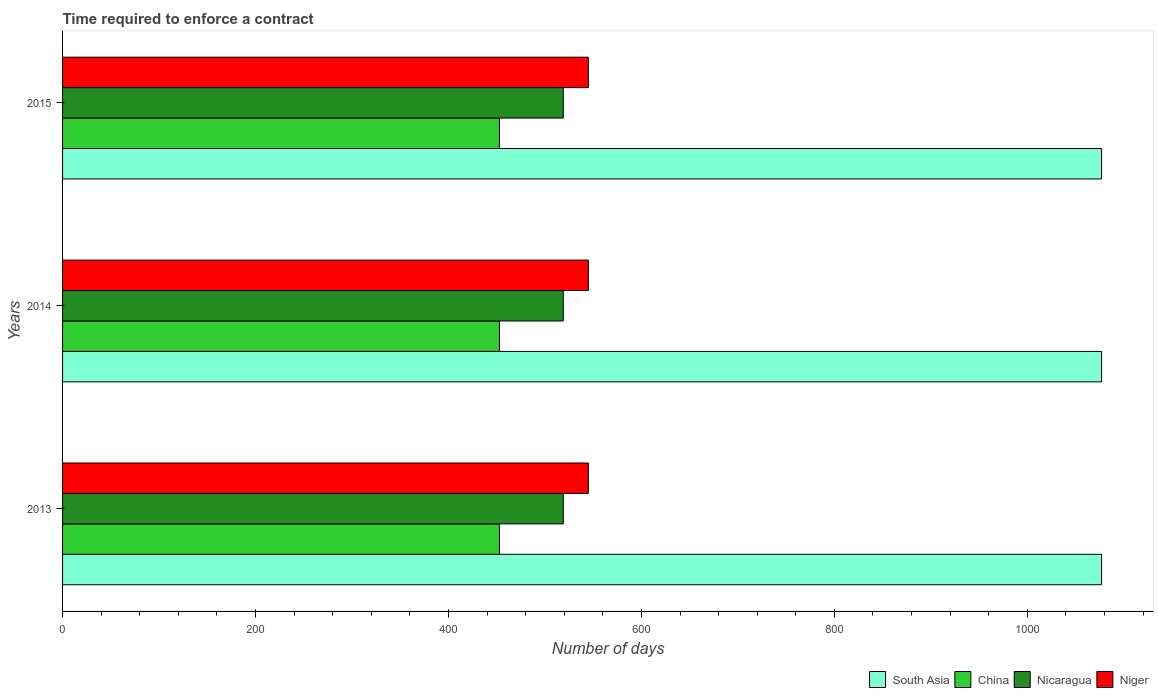Are the number of bars per tick equal to the number of legend labels?
Your answer should be compact. Yes. Are the number of bars on each tick of the Y-axis equal?
Your response must be concise. Yes. How many bars are there on the 3rd tick from the bottom?
Your answer should be very brief. 4. What is the label of the 1st group of bars from the top?
Your response must be concise. 2015. What is the number of days required to enforce a contract in Niger in 2015?
Provide a succinct answer. 545. Across all years, what is the maximum number of days required to enforce a contract in South Asia?
Your answer should be very brief. 1076.9. Across all years, what is the minimum number of days required to enforce a contract in South Asia?
Give a very brief answer. 1076.9. In which year was the number of days required to enforce a contract in China maximum?
Keep it short and to the point. 2013. What is the total number of days required to enforce a contract in Nicaragua in the graph?
Keep it short and to the point. 1557. What is the difference between the number of days required to enforce a contract in China in 2013 and that in 2014?
Keep it short and to the point. 0. What is the difference between the number of days required to enforce a contract in Niger in 2014 and the number of days required to enforce a contract in Nicaragua in 2015?
Your answer should be very brief. 26. What is the average number of days required to enforce a contract in South Asia per year?
Keep it short and to the point. 1076.9. In the year 2015, what is the difference between the number of days required to enforce a contract in Niger and number of days required to enforce a contract in China?
Offer a very short reply. 92.2. In how many years, is the number of days required to enforce a contract in China greater than 840 days?
Provide a short and direct response. 0. Is the number of days required to enforce a contract in China in 2013 less than that in 2014?
Your answer should be very brief. No. Is the difference between the number of days required to enforce a contract in Niger in 2013 and 2015 greater than the difference between the number of days required to enforce a contract in China in 2013 and 2015?
Offer a terse response. No. What is the difference between the highest and the second highest number of days required to enforce a contract in China?
Your answer should be compact. 0. Is it the case that in every year, the sum of the number of days required to enforce a contract in China and number of days required to enforce a contract in Niger is greater than the sum of number of days required to enforce a contract in South Asia and number of days required to enforce a contract in Nicaragua?
Provide a short and direct response. Yes. What does the 1st bar from the top in 2013 represents?
Offer a very short reply. Niger. What does the 4th bar from the bottom in 2013 represents?
Ensure brevity in your answer.  Niger. Is it the case that in every year, the sum of the number of days required to enforce a contract in Nicaragua and number of days required to enforce a contract in South Asia is greater than the number of days required to enforce a contract in Niger?
Keep it short and to the point. Yes. How many bars are there?
Offer a very short reply. 12. Are all the bars in the graph horizontal?
Offer a very short reply. Yes. What is the difference between two consecutive major ticks on the X-axis?
Offer a terse response. 200. Are the values on the major ticks of X-axis written in scientific E-notation?
Your response must be concise. No. Does the graph contain grids?
Keep it short and to the point. No. Where does the legend appear in the graph?
Keep it short and to the point. Bottom right. What is the title of the graph?
Your answer should be compact. Time required to enforce a contract. Does "Bangladesh" appear as one of the legend labels in the graph?
Your answer should be compact. No. What is the label or title of the X-axis?
Provide a short and direct response. Number of days. What is the Number of days of South Asia in 2013?
Offer a very short reply. 1076.9. What is the Number of days in China in 2013?
Ensure brevity in your answer.  452.8. What is the Number of days of Nicaragua in 2013?
Your response must be concise. 519. What is the Number of days in Niger in 2013?
Offer a terse response. 545. What is the Number of days of South Asia in 2014?
Offer a very short reply. 1076.9. What is the Number of days of China in 2014?
Provide a short and direct response. 452.8. What is the Number of days of Nicaragua in 2014?
Give a very brief answer. 519. What is the Number of days of Niger in 2014?
Your answer should be very brief. 545. What is the Number of days in South Asia in 2015?
Ensure brevity in your answer.  1076.9. What is the Number of days in China in 2015?
Keep it short and to the point. 452.8. What is the Number of days of Nicaragua in 2015?
Offer a very short reply. 519. What is the Number of days in Niger in 2015?
Make the answer very short. 545. Across all years, what is the maximum Number of days in South Asia?
Make the answer very short. 1076.9. Across all years, what is the maximum Number of days of China?
Offer a terse response. 452.8. Across all years, what is the maximum Number of days in Nicaragua?
Offer a very short reply. 519. Across all years, what is the maximum Number of days in Niger?
Keep it short and to the point. 545. Across all years, what is the minimum Number of days of South Asia?
Provide a short and direct response. 1076.9. Across all years, what is the minimum Number of days in China?
Give a very brief answer. 452.8. Across all years, what is the minimum Number of days in Nicaragua?
Make the answer very short. 519. Across all years, what is the minimum Number of days of Niger?
Your answer should be very brief. 545. What is the total Number of days in South Asia in the graph?
Your answer should be very brief. 3230.7. What is the total Number of days of China in the graph?
Make the answer very short. 1358.4. What is the total Number of days in Nicaragua in the graph?
Offer a very short reply. 1557. What is the total Number of days of Niger in the graph?
Your answer should be very brief. 1635. What is the difference between the Number of days in South Asia in 2013 and that in 2014?
Your response must be concise. 0. What is the difference between the Number of days in China in 2013 and that in 2014?
Ensure brevity in your answer.  0. What is the difference between the Number of days of Nicaragua in 2013 and that in 2014?
Offer a terse response. 0. What is the difference between the Number of days in China in 2013 and that in 2015?
Keep it short and to the point. 0. What is the difference between the Number of days in Nicaragua in 2014 and that in 2015?
Ensure brevity in your answer.  0. What is the difference between the Number of days in South Asia in 2013 and the Number of days in China in 2014?
Provide a short and direct response. 624.1. What is the difference between the Number of days in South Asia in 2013 and the Number of days in Nicaragua in 2014?
Ensure brevity in your answer.  557.9. What is the difference between the Number of days in South Asia in 2013 and the Number of days in Niger in 2014?
Provide a short and direct response. 531.9. What is the difference between the Number of days of China in 2013 and the Number of days of Nicaragua in 2014?
Provide a succinct answer. -66.2. What is the difference between the Number of days of China in 2013 and the Number of days of Niger in 2014?
Keep it short and to the point. -92.2. What is the difference between the Number of days of South Asia in 2013 and the Number of days of China in 2015?
Keep it short and to the point. 624.1. What is the difference between the Number of days of South Asia in 2013 and the Number of days of Nicaragua in 2015?
Make the answer very short. 557.9. What is the difference between the Number of days of South Asia in 2013 and the Number of days of Niger in 2015?
Offer a very short reply. 531.9. What is the difference between the Number of days of China in 2013 and the Number of days of Nicaragua in 2015?
Give a very brief answer. -66.2. What is the difference between the Number of days in China in 2013 and the Number of days in Niger in 2015?
Keep it short and to the point. -92.2. What is the difference between the Number of days of Nicaragua in 2013 and the Number of days of Niger in 2015?
Give a very brief answer. -26. What is the difference between the Number of days in South Asia in 2014 and the Number of days in China in 2015?
Offer a terse response. 624.1. What is the difference between the Number of days in South Asia in 2014 and the Number of days in Nicaragua in 2015?
Give a very brief answer. 557.9. What is the difference between the Number of days of South Asia in 2014 and the Number of days of Niger in 2015?
Provide a succinct answer. 531.9. What is the difference between the Number of days in China in 2014 and the Number of days in Nicaragua in 2015?
Give a very brief answer. -66.2. What is the difference between the Number of days in China in 2014 and the Number of days in Niger in 2015?
Your response must be concise. -92.2. What is the difference between the Number of days of Nicaragua in 2014 and the Number of days of Niger in 2015?
Provide a succinct answer. -26. What is the average Number of days of South Asia per year?
Offer a very short reply. 1076.9. What is the average Number of days of China per year?
Your answer should be very brief. 452.8. What is the average Number of days in Nicaragua per year?
Provide a short and direct response. 519. What is the average Number of days of Niger per year?
Make the answer very short. 545. In the year 2013, what is the difference between the Number of days in South Asia and Number of days in China?
Offer a very short reply. 624.1. In the year 2013, what is the difference between the Number of days of South Asia and Number of days of Nicaragua?
Ensure brevity in your answer.  557.9. In the year 2013, what is the difference between the Number of days in South Asia and Number of days in Niger?
Give a very brief answer. 531.9. In the year 2013, what is the difference between the Number of days of China and Number of days of Nicaragua?
Provide a short and direct response. -66.2. In the year 2013, what is the difference between the Number of days of China and Number of days of Niger?
Your answer should be compact. -92.2. In the year 2013, what is the difference between the Number of days in Nicaragua and Number of days in Niger?
Your response must be concise. -26. In the year 2014, what is the difference between the Number of days in South Asia and Number of days in China?
Make the answer very short. 624.1. In the year 2014, what is the difference between the Number of days in South Asia and Number of days in Nicaragua?
Ensure brevity in your answer.  557.9. In the year 2014, what is the difference between the Number of days in South Asia and Number of days in Niger?
Keep it short and to the point. 531.9. In the year 2014, what is the difference between the Number of days in China and Number of days in Nicaragua?
Ensure brevity in your answer.  -66.2. In the year 2014, what is the difference between the Number of days of China and Number of days of Niger?
Keep it short and to the point. -92.2. In the year 2015, what is the difference between the Number of days of South Asia and Number of days of China?
Offer a terse response. 624.1. In the year 2015, what is the difference between the Number of days of South Asia and Number of days of Nicaragua?
Your answer should be compact. 557.9. In the year 2015, what is the difference between the Number of days of South Asia and Number of days of Niger?
Your answer should be very brief. 531.9. In the year 2015, what is the difference between the Number of days of China and Number of days of Nicaragua?
Keep it short and to the point. -66.2. In the year 2015, what is the difference between the Number of days in China and Number of days in Niger?
Provide a short and direct response. -92.2. In the year 2015, what is the difference between the Number of days of Nicaragua and Number of days of Niger?
Your answer should be compact. -26. What is the ratio of the Number of days in South Asia in 2013 to that in 2014?
Your answer should be compact. 1. What is the ratio of the Number of days of China in 2013 to that in 2014?
Ensure brevity in your answer.  1. What is the ratio of the Number of days in Nicaragua in 2013 to that in 2014?
Make the answer very short. 1. What is the ratio of the Number of days of Nicaragua in 2013 to that in 2015?
Your answer should be compact. 1. What is the ratio of the Number of days of Niger in 2013 to that in 2015?
Give a very brief answer. 1. What is the ratio of the Number of days of South Asia in 2014 to that in 2015?
Offer a very short reply. 1. What is the ratio of the Number of days of China in 2014 to that in 2015?
Provide a succinct answer. 1. What is the ratio of the Number of days in Nicaragua in 2014 to that in 2015?
Offer a very short reply. 1. What is the ratio of the Number of days of Niger in 2014 to that in 2015?
Your response must be concise. 1. What is the difference between the highest and the second highest Number of days in South Asia?
Offer a terse response. 0. What is the difference between the highest and the second highest Number of days of China?
Offer a very short reply. 0. What is the difference between the highest and the second highest Number of days of Niger?
Offer a terse response. 0. What is the difference between the highest and the lowest Number of days in China?
Make the answer very short. 0. What is the difference between the highest and the lowest Number of days in Nicaragua?
Provide a succinct answer. 0. What is the difference between the highest and the lowest Number of days of Niger?
Give a very brief answer. 0. 